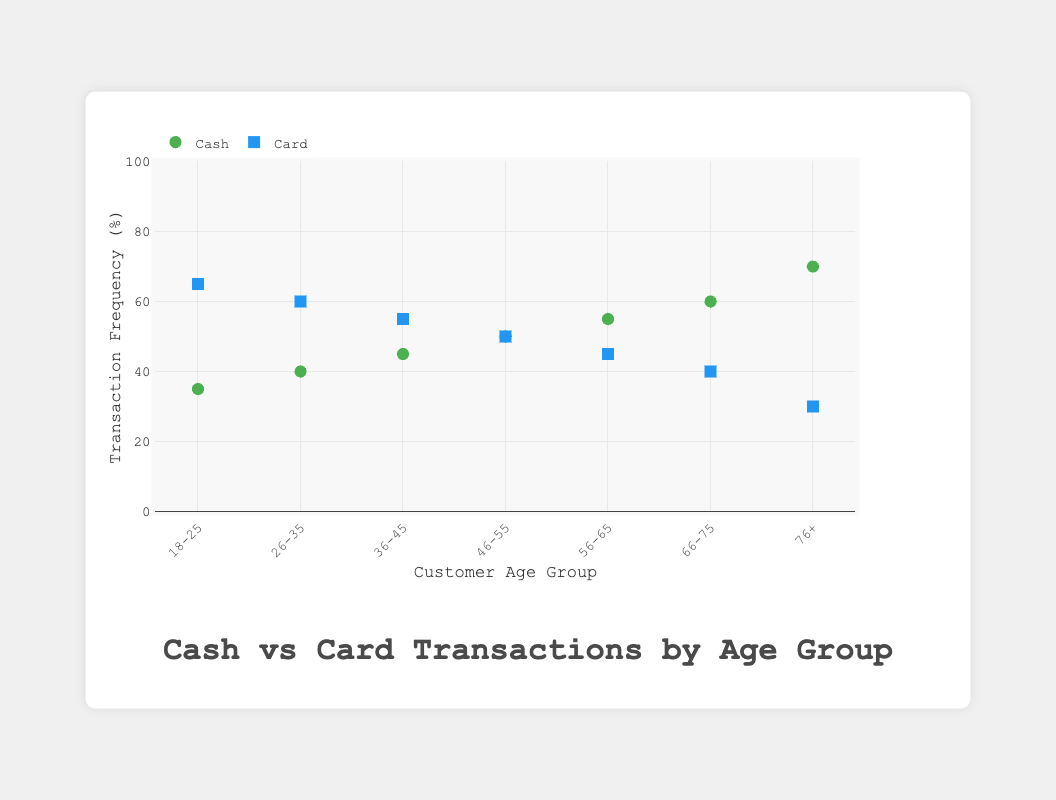what is the title of the figure? Refer to the top of the chart to find the title.
Answer: Cash vs Card Transactions by Age Group Which age group has the highest frequency of cash transactions? By looking at the scatter plot for the cash group, identify the point with the highest y-value.
Answer: 76+ What's the average frequency of cash transactions across all age groups? Sum the frequencies: 35 + 40 + 45 + 50 + 55 + 60 + 70 = 355. Then divide by the number of groups (7).
Answer: 50.71 How does the frequency of card transactions for the 18-25 age group compare to that for the 46-55 age group? Compare the y-values for the card points in the 18-25 and 46-55 age groups.
Answer: Higher for 18-25 In which age group is the frequency of cash transactions equal to the frequency of card transactions? Identify where the cash and card points have the same y-values.
Answer: 46-55 What's the total frequency of cash transactions for customers aged over 55? Sum the frequencies for "56-65", "66-75", and "76+": 55 + 60 + 70 = 185.
Answer: 185 Which transaction type is more common in the 36-45 age group? Compare the y-values for cash and card in the 36-45 age group.
Answer: Card What is the range of transaction frequencies for card payments? Identify the highest and lowest y-values for card points: Highest = 65, Lowest = 30. Difference = 65 - 30 = 35.
Answer: 35 Which transaction type shows an increasing trend in frequency as age groups go up? Observe the trend lines for cash and card points across age groups.
Answer: Cash 